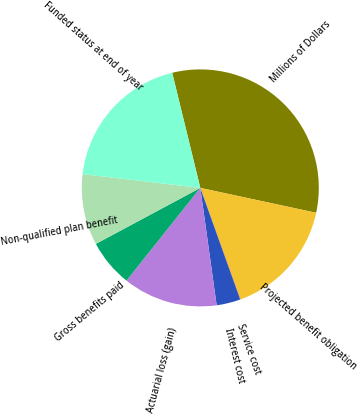<chart> <loc_0><loc_0><loc_500><loc_500><pie_chart><fcel>Millions of Dollars<fcel>Projected benefit obligation<fcel>Service cost<fcel>Interest cost<fcel>Actuarial loss (gain)<fcel>Gross benefits paid<fcel>Non-qualified plan benefit<fcel>Funded status at end of year<nl><fcel>32.18%<fcel>16.12%<fcel>0.05%<fcel>3.26%<fcel>12.9%<fcel>6.47%<fcel>9.69%<fcel>19.33%<nl></chart> 